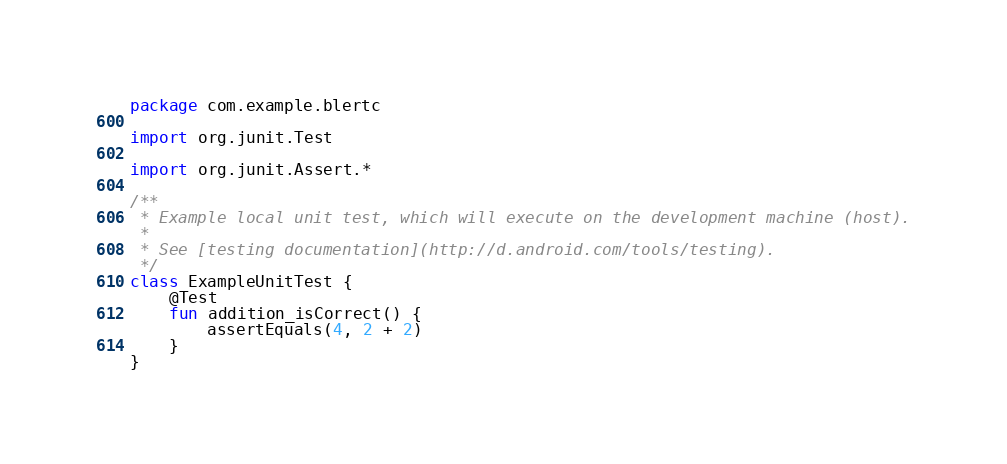<code> <loc_0><loc_0><loc_500><loc_500><_Kotlin_>package com.example.blertc

import org.junit.Test

import org.junit.Assert.*

/**
 * Example local unit test, which will execute on the development machine (host).
 *
 * See [testing documentation](http://d.android.com/tools/testing).
 */
class ExampleUnitTest {
    @Test
    fun addition_isCorrect() {
        assertEquals(4, 2 + 2)
    }
}</code> 